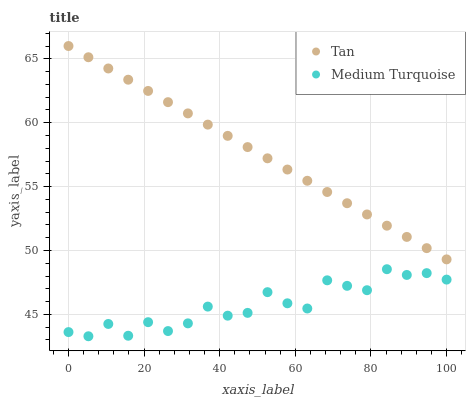Does Medium Turquoise have the minimum area under the curve?
Answer yes or no. Yes. Does Tan have the maximum area under the curve?
Answer yes or no. Yes. Does Medium Turquoise have the maximum area under the curve?
Answer yes or no. No. Is Tan the smoothest?
Answer yes or no. Yes. Is Medium Turquoise the roughest?
Answer yes or no. Yes. Is Medium Turquoise the smoothest?
Answer yes or no. No. Does Medium Turquoise have the lowest value?
Answer yes or no. Yes. Does Tan have the highest value?
Answer yes or no. Yes. Does Medium Turquoise have the highest value?
Answer yes or no. No. Is Medium Turquoise less than Tan?
Answer yes or no. Yes. Is Tan greater than Medium Turquoise?
Answer yes or no. Yes. Does Medium Turquoise intersect Tan?
Answer yes or no. No. 